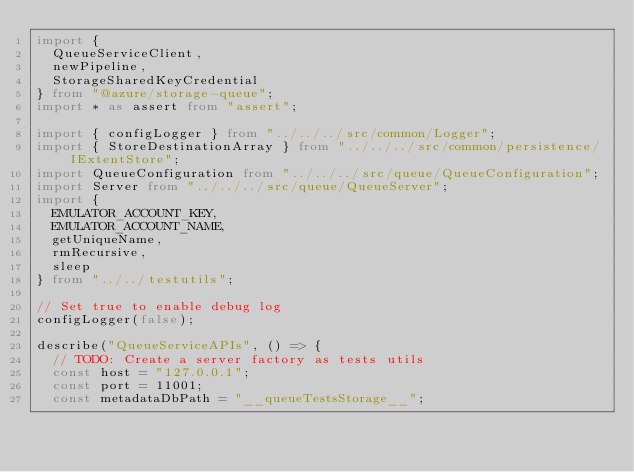<code> <loc_0><loc_0><loc_500><loc_500><_TypeScript_>import {
  QueueServiceClient,
  newPipeline,
  StorageSharedKeyCredential
} from "@azure/storage-queue";
import * as assert from "assert";

import { configLogger } from "../../../src/common/Logger";
import { StoreDestinationArray } from "../../../src/common/persistence/IExtentStore";
import QueueConfiguration from "../../../src/queue/QueueConfiguration";
import Server from "../../../src/queue/QueueServer";
import {
  EMULATOR_ACCOUNT_KEY,
  EMULATOR_ACCOUNT_NAME,
  getUniqueName,
  rmRecursive,
  sleep
} from "../../testutils";

// Set true to enable debug log
configLogger(false);

describe("QueueServiceAPIs", () => {
  // TODO: Create a server factory as tests utils
  const host = "127.0.0.1";
  const port = 11001;
  const metadataDbPath = "__queueTestsStorage__";</code> 